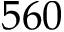Convert formula to latex. <formula><loc_0><loc_0><loc_500><loc_500>5 6 0</formula> 